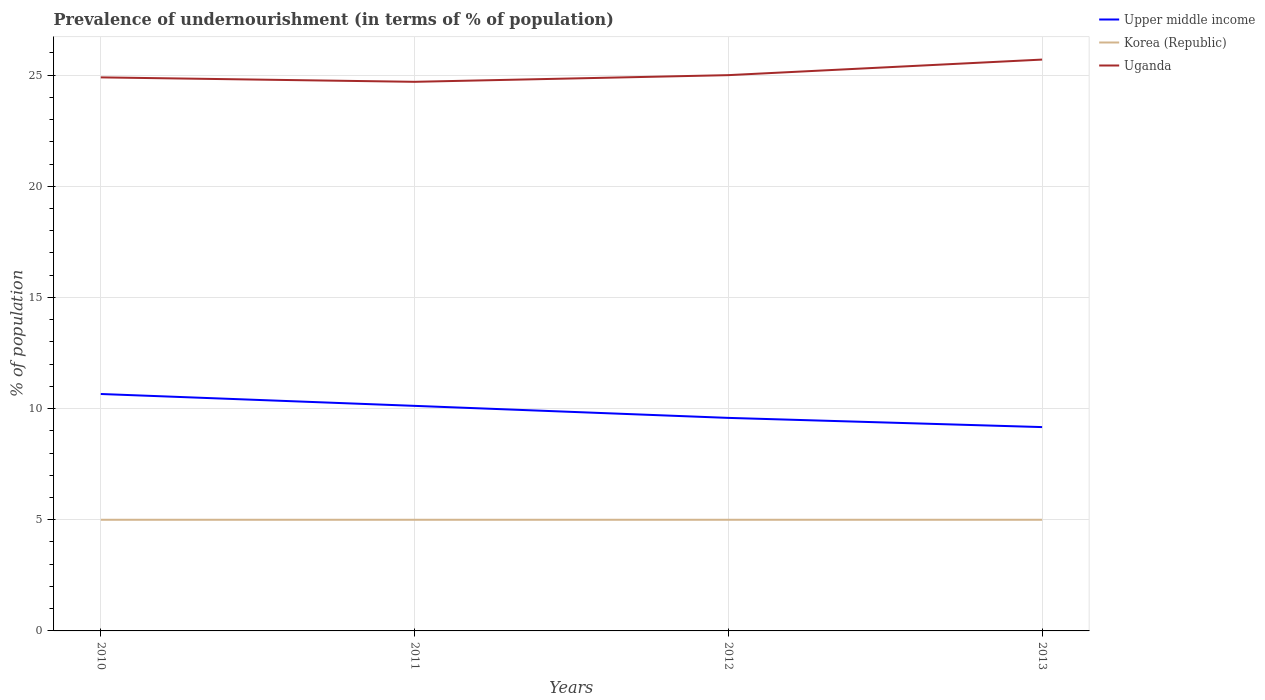Is the number of lines equal to the number of legend labels?
Your response must be concise. Yes. Across all years, what is the maximum percentage of undernourished population in Upper middle income?
Keep it short and to the point. 9.17. What is the total percentage of undernourished population in Korea (Republic) in the graph?
Ensure brevity in your answer.  0. What is the difference between the highest and the second highest percentage of undernourished population in Upper middle income?
Your answer should be compact. 1.49. What is the difference between the highest and the lowest percentage of undernourished population in Uganda?
Make the answer very short. 1. What is the difference between two consecutive major ticks on the Y-axis?
Give a very brief answer. 5. Does the graph contain any zero values?
Ensure brevity in your answer.  No. Does the graph contain grids?
Your answer should be very brief. Yes. How many legend labels are there?
Your answer should be compact. 3. What is the title of the graph?
Offer a terse response. Prevalence of undernourishment (in terms of % of population). What is the label or title of the X-axis?
Your answer should be very brief. Years. What is the label or title of the Y-axis?
Offer a very short reply. % of population. What is the % of population in Upper middle income in 2010?
Provide a succinct answer. 10.66. What is the % of population of Uganda in 2010?
Provide a short and direct response. 24.9. What is the % of population of Upper middle income in 2011?
Make the answer very short. 10.12. What is the % of population of Uganda in 2011?
Ensure brevity in your answer.  24.7. What is the % of population in Upper middle income in 2012?
Provide a short and direct response. 9.58. What is the % of population in Upper middle income in 2013?
Make the answer very short. 9.17. What is the % of population of Uganda in 2013?
Make the answer very short. 25.7. Across all years, what is the maximum % of population in Upper middle income?
Make the answer very short. 10.66. Across all years, what is the maximum % of population in Korea (Republic)?
Your answer should be compact. 5. Across all years, what is the maximum % of population in Uganda?
Your answer should be compact. 25.7. Across all years, what is the minimum % of population in Upper middle income?
Your response must be concise. 9.17. Across all years, what is the minimum % of population in Korea (Republic)?
Give a very brief answer. 5. Across all years, what is the minimum % of population in Uganda?
Give a very brief answer. 24.7. What is the total % of population in Upper middle income in the graph?
Your answer should be very brief. 39.53. What is the total % of population of Korea (Republic) in the graph?
Ensure brevity in your answer.  20. What is the total % of population in Uganda in the graph?
Offer a very short reply. 100.3. What is the difference between the % of population of Upper middle income in 2010 and that in 2011?
Ensure brevity in your answer.  0.53. What is the difference between the % of population of Uganda in 2010 and that in 2011?
Keep it short and to the point. 0.2. What is the difference between the % of population in Upper middle income in 2010 and that in 2012?
Keep it short and to the point. 1.07. What is the difference between the % of population in Korea (Republic) in 2010 and that in 2012?
Keep it short and to the point. 0. What is the difference between the % of population of Upper middle income in 2010 and that in 2013?
Offer a terse response. 1.49. What is the difference between the % of population of Upper middle income in 2011 and that in 2012?
Your response must be concise. 0.54. What is the difference between the % of population in Korea (Republic) in 2011 and that in 2012?
Offer a terse response. 0. What is the difference between the % of population of Uganda in 2011 and that in 2012?
Ensure brevity in your answer.  -0.3. What is the difference between the % of population of Upper middle income in 2011 and that in 2013?
Offer a terse response. 0.96. What is the difference between the % of population of Korea (Republic) in 2011 and that in 2013?
Your answer should be compact. 0. What is the difference between the % of population in Upper middle income in 2012 and that in 2013?
Your response must be concise. 0.41. What is the difference between the % of population in Uganda in 2012 and that in 2013?
Give a very brief answer. -0.7. What is the difference between the % of population of Upper middle income in 2010 and the % of population of Korea (Republic) in 2011?
Ensure brevity in your answer.  5.66. What is the difference between the % of population in Upper middle income in 2010 and the % of population in Uganda in 2011?
Provide a succinct answer. -14.04. What is the difference between the % of population of Korea (Republic) in 2010 and the % of population of Uganda in 2011?
Your answer should be compact. -19.7. What is the difference between the % of population of Upper middle income in 2010 and the % of population of Korea (Republic) in 2012?
Offer a very short reply. 5.66. What is the difference between the % of population in Upper middle income in 2010 and the % of population in Uganda in 2012?
Provide a short and direct response. -14.34. What is the difference between the % of population of Korea (Republic) in 2010 and the % of population of Uganda in 2012?
Make the answer very short. -20. What is the difference between the % of population of Upper middle income in 2010 and the % of population of Korea (Republic) in 2013?
Give a very brief answer. 5.66. What is the difference between the % of population of Upper middle income in 2010 and the % of population of Uganda in 2013?
Make the answer very short. -15.04. What is the difference between the % of population in Korea (Republic) in 2010 and the % of population in Uganda in 2013?
Provide a succinct answer. -20.7. What is the difference between the % of population in Upper middle income in 2011 and the % of population in Korea (Republic) in 2012?
Provide a succinct answer. 5.12. What is the difference between the % of population in Upper middle income in 2011 and the % of population in Uganda in 2012?
Your answer should be very brief. -14.88. What is the difference between the % of population of Upper middle income in 2011 and the % of population of Korea (Republic) in 2013?
Give a very brief answer. 5.12. What is the difference between the % of population in Upper middle income in 2011 and the % of population in Uganda in 2013?
Your answer should be very brief. -15.58. What is the difference between the % of population in Korea (Republic) in 2011 and the % of population in Uganda in 2013?
Give a very brief answer. -20.7. What is the difference between the % of population of Upper middle income in 2012 and the % of population of Korea (Republic) in 2013?
Offer a terse response. 4.58. What is the difference between the % of population in Upper middle income in 2012 and the % of population in Uganda in 2013?
Provide a succinct answer. -16.12. What is the difference between the % of population in Korea (Republic) in 2012 and the % of population in Uganda in 2013?
Provide a short and direct response. -20.7. What is the average % of population in Upper middle income per year?
Offer a terse response. 9.88. What is the average % of population of Korea (Republic) per year?
Ensure brevity in your answer.  5. What is the average % of population of Uganda per year?
Your answer should be compact. 25.07. In the year 2010, what is the difference between the % of population in Upper middle income and % of population in Korea (Republic)?
Provide a short and direct response. 5.66. In the year 2010, what is the difference between the % of population of Upper middle income and % of population of Uganda?
Your answer should be very brief. -14.24. In the year 2010, what is the difference between the % of population of Korea (Republic) and % of population of Uganda?
Ensure brevity in your answer.  -19.9. In the year 2011, what is the difference between the % of population in Upper middle income and % of population in Korea (Republic)?
Provide a short and direct response. 5.12. In the year 2011, what is the difference between the % of population of Upper middle income and % of population of Uganda?
Ensure brevity in your answer.  -14.58. In the year 2011, what is the difference between the % of population of Korea (Republic) and % of population of Uganda?
Your answer should be compact. -19.7. In the year 2012, what is the difference between the % of population in Upper middle income and % of population in Korea (Republic)?
Your response must be concise. 4.58. In the year 2012, what is the difference between the % of population in Upper middle income and % of population in Uganda?
Provide a succinct answer. -15.42. In the year 2012, what is the difference between the % of population in Korea (Republic) and % of population in Uganda?
Give a very brief answer. -20. In the year 2013, what is the difference between the % of population of Upper middle income and % of population of Korea (Republic)?
Your answer should be compact. 4.17. In the year 2013, what is the difference between the % of population in Upper middle income and % of population in Uganda?
Offer a very short reply. -16.53. In the year 2013, what is the difference between the % of population of Korea (Republic) and % of population of Uganda?
Provide a short and direct response. -20.7. What is the ratio of the % of population in Upper middle income in 2010 to that in 2011?
Make the answer very short. 1.05. What is the ratio of the % of population in Korea (Republic) in 2010 to that in 2011?
Offer a terse response. 1. What is the ratio of the % of population in Upper middle income in 2010 to that in 2012?
Your answer should be compact. 1.11. What is the ratio of the % of population of Uganda in 2010 to that in 2012?
Ensure brevity in your answer.  1. What is the ratio of the % of population in Upper middle income in 2010 to that in 2013?
Your response must be concise. 1.16. What is the ratio of the % of population in Korea (Republic) in 2010 to that in 2013?
Provide a short and direct response. 1. What is the ratio of the % of population in Uganda in 2010 to that in 2013?
Offer a terse response. 0.97. What is the ratio of the % of population of Upper middle income in 2011 to that in 2012?
Offer a terse response. 1.06. What is the ratio of the % of population of Korea (Republic) in 2011 to that in 2012?
Keep it short and to the point. 1. What is the ratio of the % of population of Uganda in 2011 to that in 2012?
Give a very brief answer. 0.99. What is the ratio of the % of population in Upper middle income in 2011 to that in 2013?
Your answer should be compact. 1.1. What is the ratio of the % of population in Uganda in 2011 to that in 2013?
Your answer should be compact. 0.96. What is the ratio of the % of population in Upper middle income in 2012 to that in 2013?
Provide a short and direct response. 1.05. What is the ratio of the % of population in Uganda in 2012 to that in 2013?
Offer a very short reply. 0.97. What is the difference between the highest and the second highest % of population in Upper middle income?
Offer a very short reply. 0.53. What is the difference between the highest and the lowest % of population in Upper middle income?
Provide a short and direct response. 1.49. What is the difference between the highest and the lowest % of population in Uganda?
Your answer should be very brief. 1. 